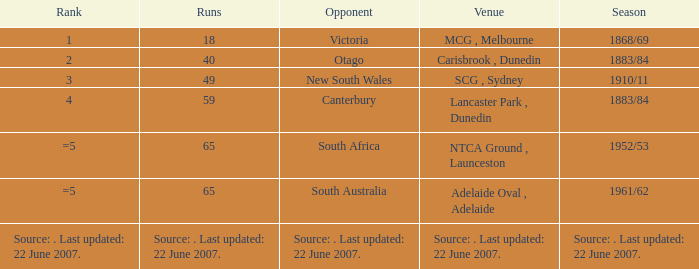Which Runs has a Rank of =5 and an Opponent of south australia? 65.0. Parse the table in full. {'header': ['Rank', 'Runs', 'Opponent', 'Venue', 'Season'], 'rows': [['1', '18', 'Victoria', 'MCG , Melbourne', '1868/69'], ['2', '40', 'Otago', 'Carisbrook , Dunedin', '1883/84'], ['3', '49', 'New South Wales', 'SCG , Sydney', '1910/11'], ['4', '59', 'Canterbury', 'Lancaster Park , Dunedin', '1883/84'], ['=5', '65', 'South Africa', 'NTCA Ground , Launceston', '1952/53'], ['=5', '65', 'South Australia', 'Adelaide Oval , Adelaide', '1961/62'], ['Source: . Last updated: 22 June 2007.', 'Source: . Last updated: 22 June 2007.', 'Source: . Last updated: 22 June 2007.', 'Source: . Last updated: 22 June 2007.', 'Source: . Last updated: 22 June 2007.']]} 